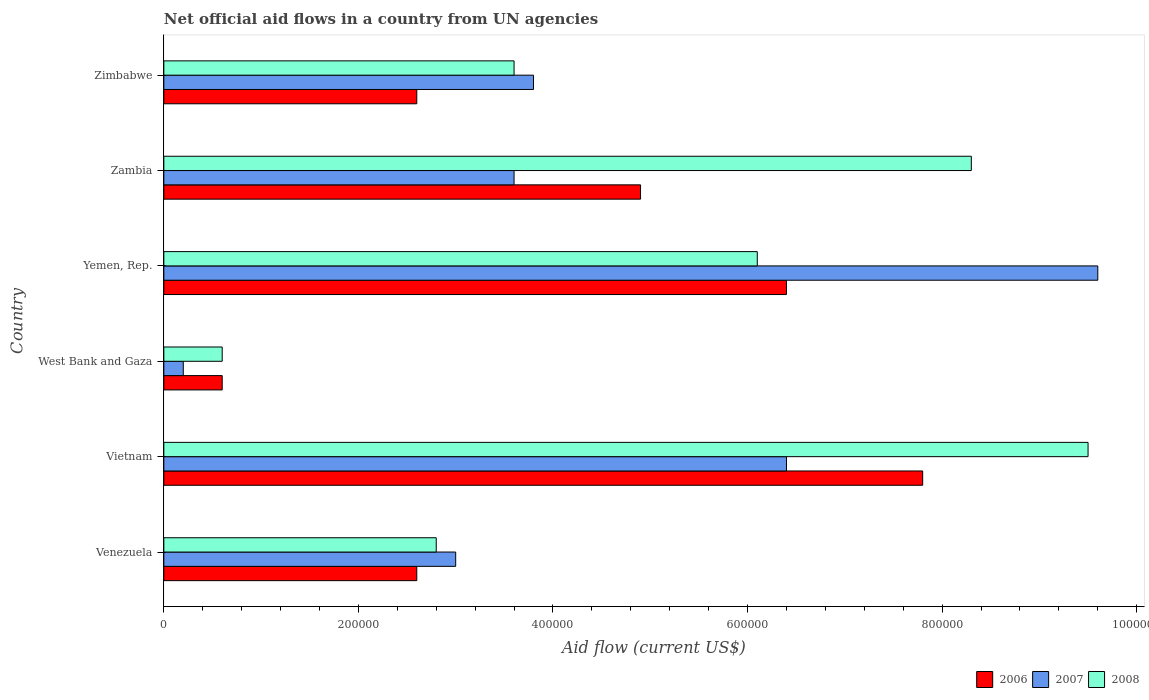How many groups of bars are there?
Give a very brief answer. 6. How many bars are there on the 3rd tick from the top?
Offer a very short reply. 3. What is the label of the 3rd group of bars from the top?
Provide a short and direct response. Yemen, Rep. In how many cases, is the number of bars for a given country not equal to the number of legend labels?
Give a very brief answer. 0. What is the net official aid flow in 2006 in Yemen, Rep.?
Offer a very short reply. 6.40e+05. Across all countries, what is the maximum net official aid flow in 2007?
Provide a succinct answer. 9.60e+05. In which country was the net official aid flow in 2007 maximum?
Ensure brevity in your answer.  Yemen, Rep. In which country was the net official aid flow in 2007 minimum?
Your answer should be very brief. West Bank and Gaza. What is the total net official aid flow in 2008 in the graph?
Give a very brief answer. 3.09e+06. What is the difference between the net official aid flow in 2007 in Yemen, Rep. and the net official aid flow in 2006 in Zimbabwe?
Offer a very short reply. 7.00e+05. What is the average net official aid flow in 2008 per country?
Give a very brief answer. 5.15e+05. What is the difference between the net official aid flow in 2008 and net official aid flow in 2007 in Zimbabwe?
Your answer should be compact. -2.00e+04. In how many countries, is the net official aid flow in 2007 greater than 120000 US$?
Offer a very short reply. 5. What is the ratio of the net official aid flow in 2007 in West Bank and Gaza to that in Yemen, Rep.?
Offer a terse response. 0.02. What is the difference between the highest and the lowest net official aid flow in 2008?
Make the answer very short. 8.90e+05. In how many countries, is the net official aid flow in 2007 greater than the average net official aid flow in 2007 taken over all countries?
Offer a very short reply. 2. Is it the case that in every country, the sum of the net official aid flow in 2006 and net official aid flow in 2008 is greater than the net official aid flow in 2007?
Your answer should be very brief. Yes. How many bars are there?
Offer a terse response. 18. How many countries are there in the graph?
Make the answer very short. 6. Are the values on the major ticks of X-axis written in scientific E-notation?
Your answer should be compact. No. Does the graph contain any zero values?
Your answer should be very brief. No. Where does the legend appear in the graph?
Provide a short and direct response. Bottom right. How many legend labels are there?
Give a very brief answer. 3. What is the title of the graph?
Your response must be concise. Net official aid flows in a country from UN agencies. What is the label or title of the X-axis?
Your answer should be compact. Aid flow (current US$). What is the label or title of the Y-axis?
Provide a succinct answer. Country. What is the Aid flow (current US$) of 2006 in Vietnam?
Your response must be concise. 7.80e+05. What is the Aid flow (current US$) in 2007 in Vietnam?
Your answer should be compact. 6.40e+05. What is the Aid flow (current US$) of 2008 in Vietnam?
Your answer should be very brief. 9.50e+05. What is the Aid flow (current US$) in 2006 in Yemen, Rep.?
Keep it short and to the point. 6.40e+05. What is the Aid flow (current US$) in 2007 in Yemen, Rep.?
Your answer should be compact. 9.60e+05. What is the Aid flow (current US$) of 2006 in Zambia?
Offer a terse response. 4.90e+05. What is the Aid flow (current US$) in 2007 in Zambia?
Keep it short and to the point. 3.60e+05. What is the Aid flow (current US$) in 2008 in Zambia?
Offer a very short reply. 8.30e+05. Across all countries, what is the maximum Aid flow (current US$) of 2006?
Offer a very short reply. 7.80e+05. Across all countries, what is the maximum Aid flow (current US$) in 2007?
Your answer should be compact. 9.60e+05. Across all countries, what is the maximum Aid flow (current US$) in 2008?
Make the answer very short. 9.50e+05. Across all countries, what is the minimum Aid flow (current US$) in 2006?
Offer a very short reply. 6.00e+04. Across all countries, what is the minimum Aid flow (current US$) in 2007?
Your response must be concise. 2.00e+04. What is the total Aid flow (current US$) in 2006 in the graph?
Your response must be concise. 2.49e+06. What is the total Aid flow (current US$) in 2007 in the graph?
Give a very brief answer. 2.66e+06. What is the total Aid flow (current US$) in 2008 in the graph?
Provide a succinct answer. 3.09e+06. What is the difference between the Aid flow (current US$) of 2006 in Venezuela and that in Vietnam?
Give a very brief answer. -5.20e+05. What is the difference between the Aid flow (current US$) of 2008 in Venezuela and that in Vietnam?
Make the answer very short. -6.70e+05. What is the difference between the Aid flow (current US$) in 2008 in Venezuela and that in West Bank and Gaza?
Your answer should be compact. 2.20e+05. What is the difference between the Aid flow (current US$) in 2006 in Venezuela and that in Yemen, Rep.?
Your answer should be very brief. -3.80e+05. What is the difference between the Aid flow (current US$) of 2007 in Venezuela and that in Yemen, Rep.?
Make the answer very short. -6.60e+05. What is the difference between the Aid flow (current US$) of 2008 in Venezuela and that in Yemen, Rep.?
Keep it short and to the point. -3.30e+05. What is the difference between the Aid flow (current US$) in 2008 in Venezuela and that in Zambia?
Make the answer very short. -5.50e+05. What is the difference between the Aid flow (current US$) in 2007 in Venezuela and that in Zimbabwe?
Your response must be concise. -8.00e+04. What is the difference between the Aid flow (current US$) of 2006 in Vietnam and that in West Bank and Gaza?
Make the answer very short. 7.20e+05. What is the difference between the Aid flow (current US$) in 2007 in Vietnam and that in West Bank and Gaza?
Your answer should be compact. 6.20e+05. What is the difference between the Aid flow (current US$) in 2008 in Vietnam and that in West Bank and Gaza?
Give a very brief answer. 8.90e+05. What is the difference between the Aid flow (current US$) of 2006 in Vietnam and that in Yemen, Rep.?
Give a very brief answer. 1.40e+05. What is the difference between the Aid flow (current US$) in 2007 in Vietnam and that in Yemen, Rep.?
Give a very brief answer. -3.20e+05. What is the difference between the Aid flow (current US$) of 2006 in Vietnam and that in Zambia?
Your answer should be very brief. 2.90e+05. What is the difference between the Aid flow (current US$) in 2008 in Vietnam and that in Zambia?
Give a very brief answer. 1.20e+05. What is the difference between the Aid flow (current US$) in 2006 in Vietnam and that in Zimbabwe?
Make the answer very short. 5.20e+05. What is the difference between the Aid flow (current US$) of 2008 in Vietnam and that in Zimbabwe?
Your response must be concise. 5.90e+05. What is the difference between the Aid flow (current US$) in 2006 in West Bank and Gaza and that in Yemen, Rep.?
Your answer should be compact. -5.80e+05. What is the difference between the Aid flow (current US$) of 2007 in West Bank and Gaza and that in Yemen, Rep.?
Ensure brevity in your answer.  -9.40e+05. What is the difference between the Aid flow (current US$) of 2008 in West Bank and Gaza and that in Yemen, Rep.?
Offer a terse response. -5.50e+05. What is the difference between the Aid flow (current US$) in 2006 in West Bank and Gaza and that in Zambia?
Provide a succinct answer. -4.30e+05. What is the difference between the Aid flow (current US$) of 2008 in West Bank and Gaza and that in Zambia?
Give a very brief answer. -7.70e+05. What is the difference between the Aid flow (current US$) of 2006 in West Bank and Gaza and that in Zimbabwe?
Make the answer very short. -2.00e+05. What is the difference between the Aid flow (current US$) in 2007 in West Bank and Gaza and that in Zimbabwe?
Your response must be concise. -3.60e+05. What is the difference between the Aid flow (current US$) of 2008 in West Bank and Gaza and that in Zimbabwe?
Offer a very short reply. -3.00e+05. What is the difference between the Aid flow (current US$) in 2007 in Yemen, Rep. and that in Zambia?
Offer a very short reply. 6.00e+05. What is the difference between the Aid flow (current US$) in 2008 in Yemen, Rep. and that in Zambia?
Provide a short and direct response. -2.20e+05. What is the difference between the Aid flow (current US$) in 2007 in Yemen, Rep. and that in Zimbabwe?
Provide a succinct answer. 5.80e+05. What is the difference between the Aid flow (current US$) in 2008 in Yemen, Rep. and that in Zimbabwe?
Provide a succinct answer. 2.50e+05. What is the difference between the Aid flow (current US$) in 2008 in Zambia and that in Zimbabwe?
Offer a very short reply. 4.70e+05. What is the difference between the Aid flow (current US$) of 2006 in Venezuela and the Aid flow (current US$) of 2007 in Vietnam?
Keep it short and to the point. -3.80e+05. What is the difference between the Aid flow (current US$) in 2006 in Venezuela and the Aid flow (current US$) in 2008 in Vietnam?
Your response must be concise. -6.90e+05. What is the difference between the Aid flow (current US$) in 2007 in Venezuela and the Aid flow (current US$) in 2008 in Vietnam?
Offer a terse response. -6.50e+05. What is the difference between the Aid flow (current US$) of 2006 in Venezuela and the Aid flow (current US$) of 2008 in West Bank and Gaza?
Offer a very short reply. 2.00e+05. What is the difference between the Aid flow (current US$) of 2006 in Venezuela and the Aid flow (current US$) of 2007 in Yemen, Rep.?
Your response must be concise. -7.00e+05. What is the difference between the Aid flow (current US$) in 2006 in Venezuela and the Aid flow (current US$) in 2008 in Yemen, Rep.?
Give a very brief answer. -3.50e+05. What is the difference between the Aid flow (current US$) of 2007 in Venezuela and the Aid flow (current US$) of 2008 in Yemen, Rep.?
Make the answer very short. -3.10e+05. What is the difference between the Aid flow (current US$) of 2006 in Venezuela and the Aid flow (current US$) of 2008 in Zambia?
Give a very brief answer. -5.70e+05. What is the difference between the Aid flow (current US$) of 2007 in Venezuela and the Aid flow (current US$) of 2008 in Zambia?
Provide a succinct answer. -5.30e+05. What is the difference between the Aid flow (current US$) of 2006 in Vietnam and the Aid flow (current US$) of 2007 in West Bank and Gaza?
Offer a terse response. 7.60e+05. What is the difference between the Aid flow (current US$) in 2006 in Vietnam and the Aid flow (current US$) in 2008 in West Bank and Gaza?
Make the answer very short. 7.20e+05. What is the difference between the Aid flow (current US$) of 2007 in Vietnam and the Aid flow (current US$) of 2008 in West Bank and Gaza?
Ensure brevity in your answer.  5.80e+05. What is the difference between the Aid flow (current US$) of 2006 in Vietnam and the Aid flow (current US$) of 2007 in Yemen, Rep.?
Your answer should be compact. -1.80e+05. What is the difference between the Aid flow (current US$) in 2006 in Vietnam and the Aid flow (current US$) in 2008 in Yemen, Rep.?
Ensure brevity in your answer.  1.70e+05. What is the difference between the Aid flow (current US$) of 2007 in Vietnam and the Aid flow (current US$) of 2008 in Yemen, Rep.?
Provide a short and direct response. 3.00e+04. What is the difference between the Aid flow (current US$) in 2006 in Vietnam and the Aid flow (current US$) in 2007 in Zambia?
Make the answer very short. 4.20e+05. What is the difference between the Aid flow (current US$) in 2006 in Vietnam and the Aid flow (current US$) in 2008 in Zambia?
Provide a short and direct response. -5.00e+04. What is the difference between the Aid flow (current US$) of 2006 in Vietnam and the Aid flow (current US$) of 2007 in Zimbabwe?
Offer a very short reply. 4.00e+05. What is the difference between the Aid flow (current US$) of 2006 in West Bank and Gaza and the Aid flow (current US$) of 2007 in Yemen, Rep.?
Provide a succinct answer. -9.00e+05. What is the difference between the Aid flow (current US$) of 2006 in West Bank and Gaza and the Aid flow (current US$) of 2008 in Yemen, Rep.?
Provide a succinct answer. -5.50e+05. What is the difference between the Aid flow (current US$) in 2007 in West Bank and Gaza and the Aid flow (current US$) in 2008 in Yemen, Rep.?
Give a very brief answer. -5.90e+05. What is the difference between the Aid flow (current US$) in 2006 in West Bank and Gaza and the Aid flow (current US$) in 2007 in Zambia?
Your response must be concise. -3.00e+05. What is the difference between the Aid flow (current US$) of 2006 in West Bank and Gaza and the Aid flow (current US$) of 2008 in Zambia?
Ensure brevity in your answer.  -7.70e+05. What is the difference between the Aid flow (current US$) of 2007 in West Bank and Gaza and the Aid flow (current US$) of 2008 in Zambia?
Offer a terse response. -8.10e+05. What is the difference between the Aid flow (current US$) of 2006 in West Bank and Gaza and the Aid flow (current US$) of 2007 in Zimbabwe?
Offer a terse response. -3.20e+05. What is the difference between the Aid flow (current US$) of 2006 in West Bank and Gaza and the Aid flow (current US$) of 2008 in Zimbabwe?
Give a very brief answer. -3.00e+05. What is the difference between the Aid flow (current US$) of 2007 in West Bank and Gaza and the Aid flow (current US$) of 2008 in Zimbabwe?
Ensure brevity in your answer.  -3.40e+05. What is the difference between the Aid flow (current US$) of 2006 in Yemen, Rep. and the Aid flow (current US$) of 2007 in Zambia?
Give a very brief answer. 2.80e+05. What is the difference between the Aid flow (current US$) in 2007 in Yemen, Rep. and the Aid flow (current US$) in 2008 in Zambia?
Your answer should be compact. 1.30e+05. What is the difference between the Aid flow (current US$) of 2006 in Yemen, Rep. and the Aid flow (current US$) of 2007 in Zimbabwe?
Provide a short and direct response. 2.60e+05. What is the difference between the Aid flow (current US$) of 2006 in Yemen, Rep. and the Aid flow (current US$) of 2008 in Zimbabwe?
Keep it short and to the point. 2.80e+05. What is the difference between the Aid flow (current US$) in 2006 in Zambia and the Aid flow (current US$) in 2008 in Zimbabwe?
Give a very brief answer. 1.30e+05. What is the average Aid flow (current US$) of 2006 per country?
Provide a succinct answer. 4.15e+05. What is the average Aid flow (current US$) in 2007 per country?
Make the answer very short. 4.43e+05. What is the average Aid flow (current US$) of 2008 per country?
Keep it short and to the point. 5.15e+05. What is the difference between the Aid flow (current US$) in 2006 and Aid flow (current US$) in 2007 in Venezuela?
Provide a succinct answer. -4.00e+04. What is the difference between the Aid flow (current US$) in 2006 and Aid flow (current US$) in 2008 in Venezuela?
Offer a terse response. -2.00e+04. What is the difference between the Aid flow (current US$) in 2006 and Aid flow (current US$) in 2007 in Vietnam?
Provide a short and direct response. 1.40e+05. What is the difference between the Aid flow (current US$) of 2006 and Aid flow (current US$) of 2008 in Vietnam?
Keep it short and to the point. -1.70e+05. What is the difference between the Aid flow (current US$) of 2007 and Aid flow (current US$) of 2008 in Vietnam?
Your answer should be very brief. -3.10e+05. What is the difference between the Aid flow (current US$) in 2006 and Aid flow (current US$) in 2007 in West Bank and Gaza?
Give a very brief answer. 4.00e+04. What is the difference between the Aid flow (current US$) of 2007 and Aid flow (current US$) of 2008 in West Bank and Gaza?
Your answer should be compact. -4.00e+04. What is the difference between the Aid flow (current US$) of 2006 and Aid flow (current US$) of 2007 in Yemen, Rep.?
Keep it short and to the point. -3.20e+05. What is the difference between the Aid flow (current US$) of 2006 and Aid flow (current US$) of 2007 in Zambia?
Provide a short and direct response. 1.30e+05. What is the difference between the Aid flow (current US$) of 2007 and Aid flow (current US$) of 2008 in Zambia?
Your answer should be compact. -4.70e+05. What is the difference between the Aid flow (current US$) in 2006 and Aid flow (current US$) in 2007 in Zimbabwe?
Ensure brevity in your answer.  -1.20e+05. What is the difference between the Aid flow (current US$) of 2006 and Aid flow (current US$) of 2008 in Zimbabwe?
Provide a succinct answer. -1.00e+05. What is the difference between the Aid flow (current US$) of 2007 and Aid flow (current US$) of 2008 in Zimbabwe?
Your answer should be compact. 2.00e+04. What is the ratio of the Aid flow (current US$) of 2006 in Venezuela to that in Vietnam?
Offer a terse response. 0.33. What is the ratio of the Aid flow (current US$) in 2007 in Venezuela to that in Vietnam?
Your answer should be compact. 0.47. What is the ratio of the Aid flow (current US$) of 2008 in Venezuela to that in Vietnam?
Offer a terse response. 0.29. What is the ratio of the Aid flow (current US$) of 2006 in Venezuela to that in West Bank and Gaza?
Ensure brevity in your answer.  4.33. What is the ratio of the Aid flow (current US$) of 2008 in Venezuela to that in West Bank and Gaza?
Your response must be concise. 4.67. What is the ratio of the Aid flow (current US$) of 2006 in Venezuela to that in Yemen, Rep.?
Offer a terse response. 0.41. What is the ratio of the Aid flow (current US$) in 2007 in Venezuela to that in Yemen, Rep.?
Give a very brief answer. 0.31. What is the ratio of the Aid flow (current US$) in 2008 in Venezuela to that in Yemen, Rep.?
Your answer should be compact. 0.46. What is the ratio of the Aid flow (current US$) in 2006 in Venezuela to that in Zambia?
Give a very brief answer. 0.53. What is the ratio of the Aid flow (current US$) in 2008 in Venezuela to that in Zambia?
Offer a very short reply. 0.34. What is the ratio of the Aid flow (current US$) in 2006 in Venezuela to that in Zimbabwe?
Provide a short and direct response. 1. What is the ratio of the Aid flow (current US$) of 2007 in Venezuela to that in Zimbabwe?
Keep it short and to the point. 0.79. What is the ratio of the Aid flow (current US$) of 2006 in Vietnam to that in West Bank and Gaza?
Provide a short and direct response. 13. What is the ratio of the Aid flow (current US$) of 2008 in Vietnam to that in West Bank and Gaza?
Provide a succinct answer. 15.83. What is the ratio of the Aid flow (current US$) of 2006 in Vietnam to that in Yemen, Rep.?
Your answer should be compact. 1.22. What is the ratio of the Aid flow (current US$) of 2008 in Vietnam to that in Yemen, Rep.?
Offer a terse response. 1.56. What is the ratio of the Aid flow (current US$) in 2006 in Vietnam to that in Zambia?
Give a very brief answer. 1.59. What is the ratio of the Aid flow (current US$) of 2007 in Vietnam to that in Zambia?
Ensure brevity in your answer.  1.78. What is the ratio of the Aid flow (current US$) in 2008 in Vietnam to that in Zambia?
Your answer should be compact. 1.14. What is the ratio of the Aid flow (current US$) of 2007 in Vietnam to that in Zimbabwe?
Provide a short and direct response. 1.68. What is the ratio of the Aid flow (current US$) in 2008 in Vietnam to that in Zimbabwe?
Offer a terse response. 2.64. What is the ratio of the Aid flow (current US$) of 2006 in West Bank and Gaza to that in Yemen, Rep.?
Your answer should be compact. 0.09. What is the ratio of the Aid flow (current US$) in 2007 in West Bank and Gaza to that in Yemen, Rep.?
Your answer should be very brief. 0.02. What is the ratio of the Aid flow (current US$) in 2008 in West Bank and Gaza to that in Yemen, Rep.?
Ensure brevity in your answer.  0.1. What is the ratio of the Aid flow (current US$) of 2006 in West Bank and Gaza to that in Zambia?
Your response must be concise. 0.12. What is the ratio of the Aid flow (current US$) in 2007 in West Bank and Gaza to that in Zambia?
Offer a terse response. 0.06. What is the ratio of the Aid flow (current US$) in 2008 in West Bank and Gaza to that in Zambia?
Your answer should be very brief. 0.07. What is the ratio of the Aid flow (current US$) in 2006 in West Bank and Gaza to that in Zimbabwe?
Make the answer very short. 0.23. What is the ratio of the Aid flow (current US$) in 2007 in West Bank and Gaza to that in Zimbabwe?
Ensure brevity in your answer.  0.05. What is the ratio of the Aid flow (current US$) of 2006 in Yemen, Rep. to that in Zambia?
Your response must be concise. 1.31. What is the ratio of the Aid flow (current US$) of 2007 in Yemen, Rep. to that in Zambia?
Provide a short and direct response. 2.67. What is the ratio of the Aid flow (current US$) in 2008 in Yemen, Rep. to that in Zambia?
Offer a terse response. 0.73. What is the ratio of the Aid flow (current US$) of 2006 in Yemen, Rep. to that in Zimbabwe?
Your response must be concise. 2.46. What is the ratio of the Aid flow (current US$) in 2007 in Yemen, Rep. to that in Zimbabwe?
Offer a terse response. 2.53. What is the ratio of the Aid flow (current US$) of 2008 in Yemen, Rep. to that in Zimbabwe?
Your response must be concise. 1.69. What is the ratio of the Aid flow (current US$) in 2006 in Zambia to that in Zimbabwe?
Offer a very short reply. 1.88. What is the ratio of the Aid flow (current US$) of 2008 in Zambia to that in Zimbabwe?
Make the answer very short. 2.31. What is the difference between the highest and the second highest Aid flow (current US$) of 2007?
Your answer should be very brief. 3.20e+05. What is the difference between the highest and the lowest Aid flow (current US$) of 2006?
Your response must be concise. 7.20e+05. What is the difference between the highest and the lowest Aid flow (current US$) in 2007?
Your answer should be compact. 9.40e+05. What is the difference between the highest and the lowest Aid flow (current US$) of 2008?
Give a very brief answer. 8.90e+05. 